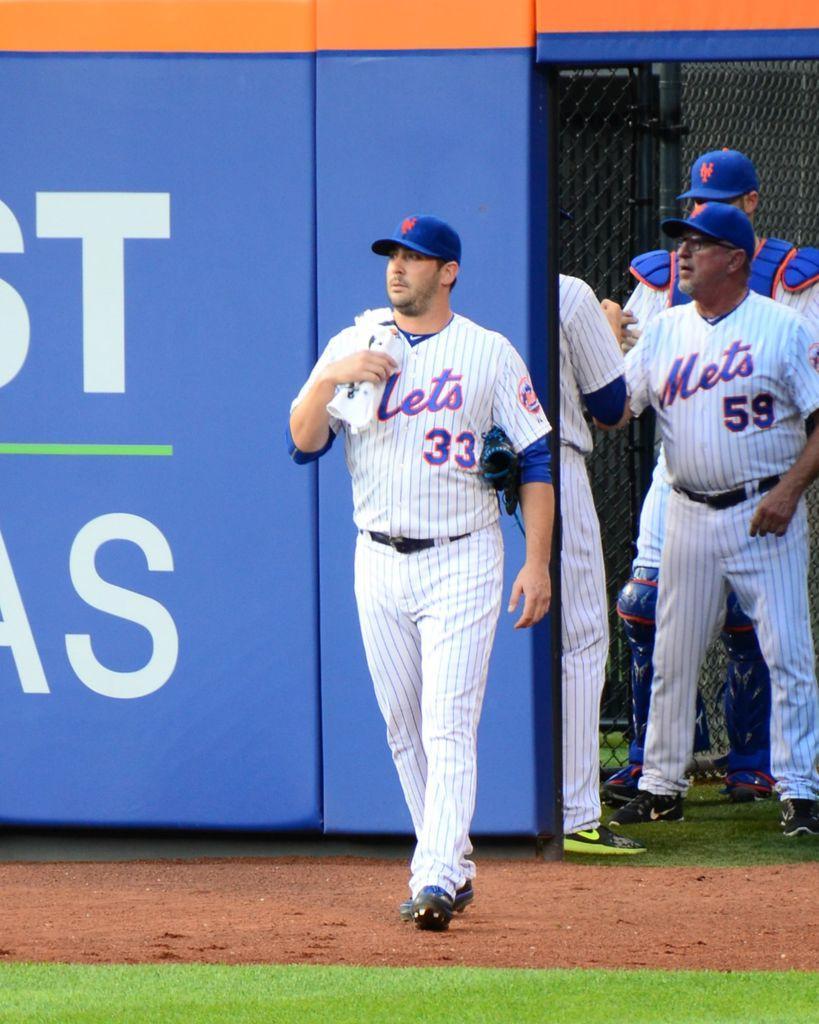How would you summarize this image in a sentence or two? This picture might be taken inside a playground. In this image, in the middle, we can see a man walking on the land. On the right side, we can see three men are standing on the grass. In the background, we can see a hoarding, net fence. At the bottom, we can see a land and a grass. 